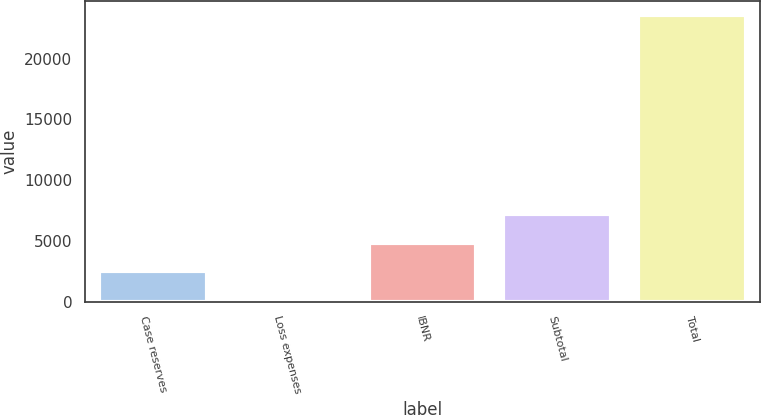Convert chart to OTSL. <chart><loc_0><loc_0><loc_500><loc_500><bar_chart><fcel>Case reserves<fcel>Loss expenses<fcel>IBNR<fcel>Subtotal<fcel>Total<nl><fcel>2516.7<fcel>175<fcel>4858.4<fcel>7200.1<fcel>23592<nl></chart> 